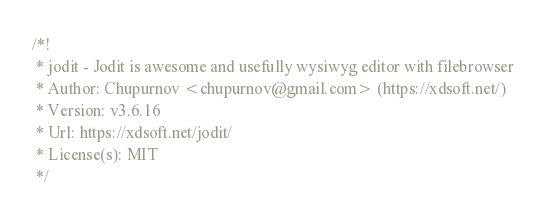Convert code to text. <code><loc_0><loc_0><loc_500><loc_500><_CSS_>/*!
 * jodit - Jodit is awesome and usefully wysiwyg editor with filebrowser
 * Author: Chupurnov <chupurnov@gmail.com> (https://xdsoft.net/)
 * Version: v3.6.16
 * Url: https://xdsoft.net/jodit/
 * License(s): MIT
 */</code> 